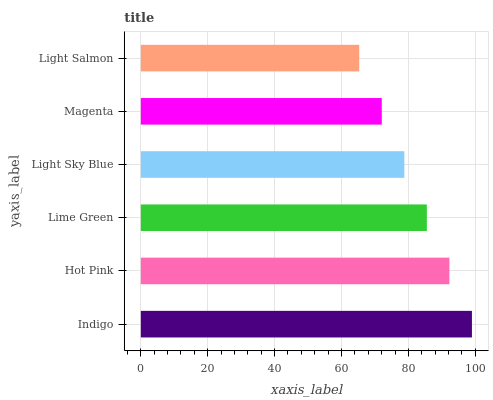Is Light Salmon the minimum?
Answer yes or no. Yes. Is Indigo the maximum?
Answer yes or no. Yes. Is Hot Pink the minimum?
Answer yes or no. No. Is Hot Pink the maximum?
Answer yes or no. No. Is Indigo greater than Hot Pink?
Answer yes or no. Yes. Is Hot Pink less than Indigo?
Answer yes or no. Yes. Is Hot Pink greater than Indigo?
Answer yes or no. No. Is Indigo less than Hot Pink?
Answer yes or no. No. Is Lime Green the high median?
Answer yes or no. Yes. Is Light Sky Blue the low median?
Answer yes or no. Yes. Is Magenta the high median?
Answer yes or no. No. Is Hot Pink the low median?
Answer yes or no. No. 